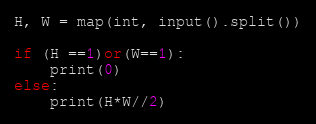<code> <loc_0><loc_0><loc_500><loc_500><_Python_>H, W = map(int, input().split())

if (H ==1)or(W==1):
    print(0)
else:
    print(H*W//2)</code> 